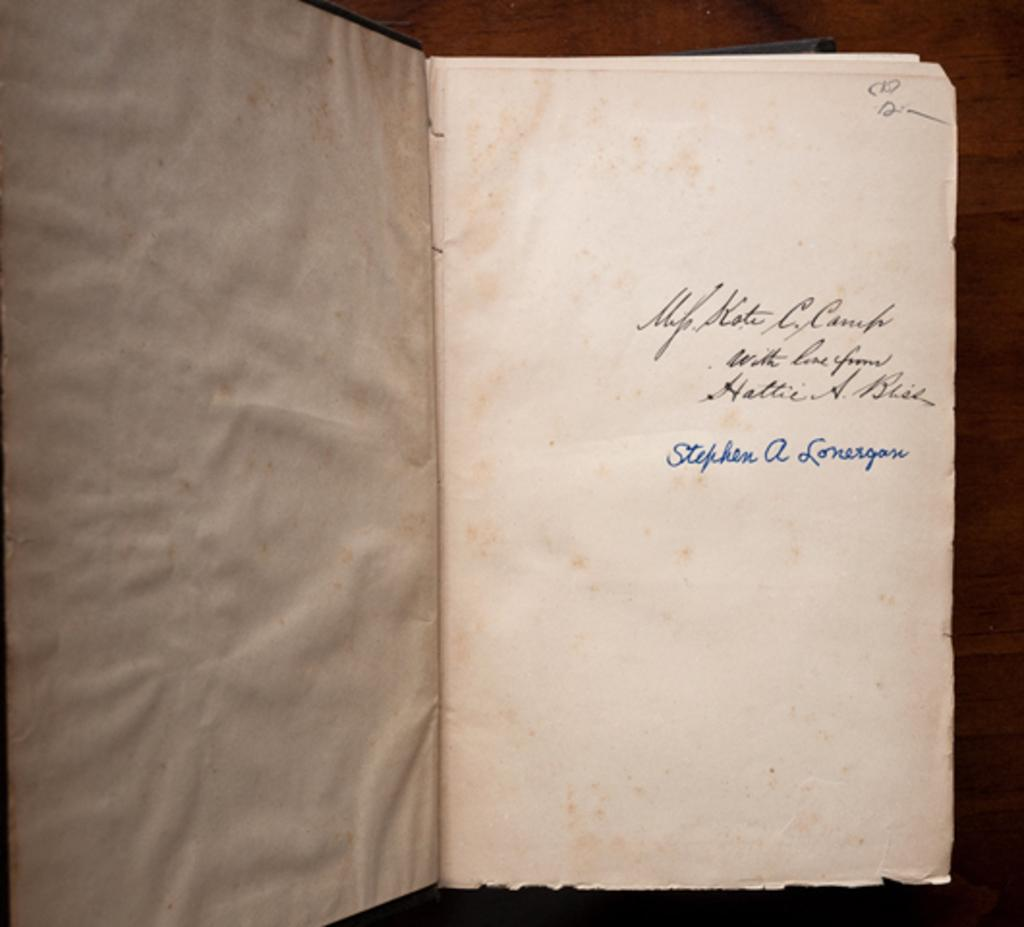<image>
Relay a brief, clear account of the picture shown. Open book showing the name Stephen A Lonergase on it. 